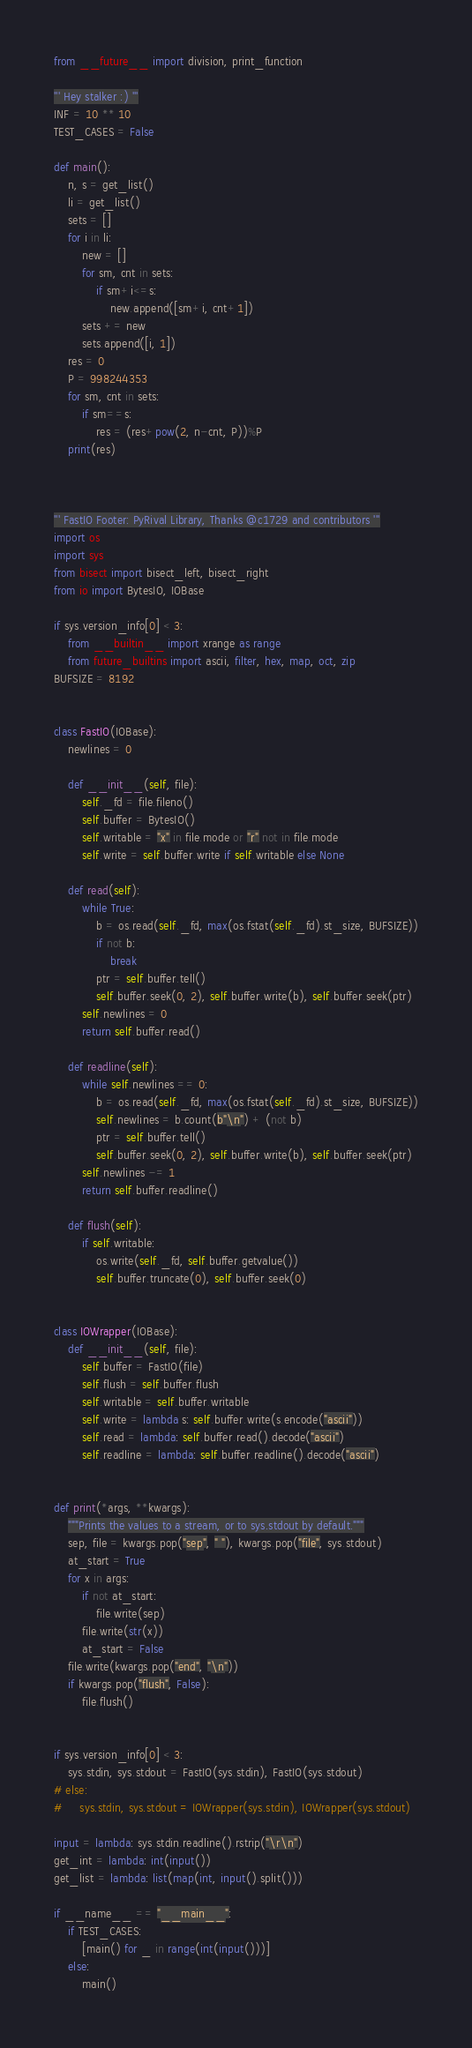Convert code to text. <code><loc_0><loc_0><loc_500><loc_500><_Python_>from __future__ import division, print_function

''' Hey stalker :) '''
INF = 10 ** 10
TEST_CASES = False

def main():
    n, s = get_list()
    li = get_list()
    sets = []
    for i in li:
        new = []
        for sm, cnt in sets:
            if sm+i<=s:
                new.append([sm+i, cnt+1])
        sets += new
        sets.append([i, 1])
    res = 0
    P = 998244353
    for sm, cnt in sets:
        if sm==s:
            res = (res+pow(2, n-cnt, P))%P
    print(res)



''' FastIO Footer: PyRival Library, Thanks @c1729 and contributors '''
import os
import sys
from bisect import bisect_left, bisect_right
from io import BytesIO, IOBase

if sys.version_info[0] < 3:
    from __builtin__ import xrange as range
    from future_builtins import ascii, filter, hex, map, oct, zip
BUFSIZE = 8192


class FastIO(IOBase):
    newlines = 0

    def __init__(self, file):
        self._fd = file.fileno()
        self.buffer = BytesIO()
        self.writable = "x" in file.mode or "r" not in file.mode
        self.write = self.buffer.write if self.writable else None

    def read(self):
        while True:
            b = os.read(self._fd, max(os.fstat(self._fd).st_size, BUFSIZE))
            if not b:
                break
            ptr = self.buffer.tell()
            self.buffer.seek(0, 2), self.buffer.write(b), self.buffer.seek(ptr)
        self.newlines = 0
        return self.buffer.read()

    def readline(self):
        while self.newlines == 0:
            b = os.read(self._fd, max(os.fstat(self._fd).st_size, BUFSIZE))
            self.newlines = b.count(b"\n") + (not b)
            ptr = self.buffer.tell()
            self.buffer.seek(0, 2), self.buffer.write(b), self.buffer.seek(ptr)
        self.newlines -= 1
        return self.buffer.readline()

    def flush(self):
        if self.writable:
            os.write(self._fd, self.buffer.getvalue())
            self.buffer.truncate(0), self.buffer.seek(0)


class IOWrapper(IOBase):
    def __init__(self, file):
        self.buffer = FastIO(file)
        self.flush = self.buffer.flush
        self.writable = self.buffer.writable
        self.write = lambda s: self.buffer.write(s.encode("ascii"))
        self.read = lambda: self.buffer.read().decode("ascii")
        self.readline = lambda: self.buffer.readline().decode("ascii")


def print(*args, **kwargs):
    """Prints the values to a stream, or to sys.stdout by default."""
    sep, file = kwargs.pop("sep", " "), kwargs.pop("file", sys.stdout)
    at_start = True
    for x in args:
        if not at_start:
            file.write(sep)
        file.write(str(x))
        at_start = False
    file.write(kwargs.pop("end", "\n"))
    if kwargs.pop("flush", False):
        file.flush()


if sys.version_info[0] < 3:
    sys.stdin, sys.stdout = FastIO(sys.stdin), FastIO(sys.stdout)
# else:
#     sys.stdin, sys.stdout = IOWrapper(sys.stdin), IOWrapper(sys.stdout)

input = lambda: sys.stdin.readline().rstrip("\r\n")
get_int = lambda: int(input())
get_list = lambda: list(map(int, input().split()))

if __name__ == "__main__":
    if TEST_CASES:
        [main() for _ in range(int(input()))]
    else:
        main()
</code> 